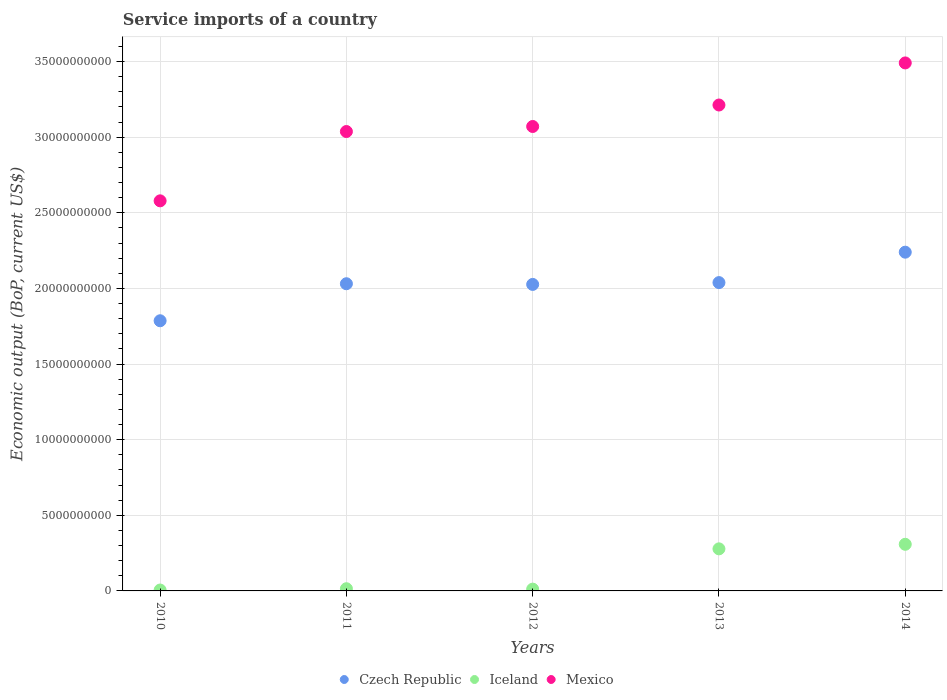How many different coloured dotlines are there?
Ensure brevity in your answer.  3. What is the service imports in Mexico in 2011?
Keep it short and to the point. 3.04e+1. Across all years, what is the maximum service imports in Iceland?
Provide a succinct answer. 3.08e+09. Across all years, what is the minimum service imports in Iceland?
Keep it short and to the point. 5.89e+07. In which year was the service imports in Czech Republic maximum?
Provide a short and direct response. 2014. What is the total service imports in Mexico in the graph?
Provide a succinct answer. 1.54e+11. What is the difference between the service imports in Mexico in 2010 and that in 2012?
Offer a very short reply. -4.92e+09. What is the difference between the service imports in Iceland in 2011 and the service imports in Mexico in 2012?
Ensure brevity in your answer.  -3.06e+1. What is the average service imports in Iceland per year?
Your response must be concise. 1.24e+09. In the year 2012, what is the difference between the service imports in Czech Republic and service imports in Mexico?
Your response must be concise. -1.04e+1. What is the ratio of the service imports in Mexico in 2011 to that in 2012?
Your answer should be compact. 0.99. Is the service imports in Mexico in 2011 less than that in 2014?
Keep it short and to the point. Yes. What is the difference between the highest and the second highest service imports in Mexico?
Offer a terse response. 2.78e+09. What is the difference between the highest and the lowest service imports in Czech Republic?
Give a very brief answer. 4.53e+09. In how many years, is the service imports in Czech Republic greater than the average service imports in Czech Republic taken over all years?
Offer a terse response. 4. Is it the case that in every year, the sum of the service imports in Iceland and service imports in Czech Republic  is greater than the service imports in Mexico?
Your answer should be compact. No. Does the service imports in Iceland monotonically increase over the years?
Make the answer very short. No. Is the service imports in Czech Republic strictly less than the service imports in Mexico over the years?
Offer a terse response. Yes. How many years are there in the graph?
Provide a short and direct response. 5. Are the values on the major ticks of Y-axis written in scientific E-notation?
Provide a short and direct response. No. Does the graph contain grids?
Your response must be concise. Yes. What is the title of the graph?
Give a very brief answer. Service imports of a country. What is the label or title of the Y-axis?
Offer a very short reply. Economic output (BoP, current US$). What is the Economic output (BoP, current US$) in Czech Republic in 2010?
Provide a short and direct response. 1.79e+1. What is the Economic output (BoP, current US$) in Iceland in 2010?
Your answer should be very brief. 5.89e+07. What is the Economic output (BoP, current US$) in Mexico in 2010?
Provide a succinct answer. 2.58e+1. What is the Economic output (BoP, current US$) of Czech Republic in 2011?
Your answer should be very brief. 2.03e+1. What is the Economic output (BoP, current US$) in Iceland in 2011?
Provide a succinct answer. 1.45e+08. What is the Economic output (BoP, current US$) of Mexico in 2011?
Keep it short and to the point. 3.04e+1. What is the Economic output (BoP, current US$) in Czech Republic in 2012?
Keep it short and to the point. 2.03e+1. What is the Economic output (BoP, current US$) of Iceland in 2012?
Provide a succinct answer. 1.18e+08. What is the Economic output (BoP, current US$) in Mexico in 2012?
Your answer should be very brief. 3.07e+1. What is the Economic output (BoP, current US$) in Czech Republic in 2013?
Provide a short and direct response. 2.04e+1. What is the Economic output (BoP, current US$) in Iceland in 2013?
Ensure brevity in your answer.  2.78e+09. What is the Economic output (BoP, current US$) in Mexico in 2013?
Your response must be concise. 3.21e+1. What is the Economic output (BoP, current US$) of Czech Republic in 2014?
Provide a short and direct response. 2.24e+1. What is the Economic output (BoP, current US$) of Iceland in 2014?
Keep it short and to the point. 3.08e+09. What is the Economic output (BoP, current US$) in Mexico in 2014?
Provide a short and direct response. 3.49e+1. Across all years, what is the maximum Economic output (BoP, current US$) in Czech Republic?
Make the answer very short. 2.24e+1. Across all years, what is the maximum Economic output (BoP, current US$) of Iceland?
Make the answer very short. 3.08e+09. Across all years, what is the maximum Economic output (BoP, current US$) in Mexico?
Provide a short and direct response. 3.49e+1. Across all years, what is the minimum Economic output (BoP, current US$) in Czech Republic?
Provide a succinct answer. 1.79e+1. Across all years, what is the minimum Economic output (BoP, current US$) of Iceland?
Provide a short and direct response. 5.89e+07. Across all years, what is the minimum Economic output (BoP, current US$) of Mexico?
Make the answer very short. 2.58e+1. What is the total Economic output (BoP, current US$) in Czech Republic in the graph?
Your answer should be compact. 1.01e+11. What is the total Economic output (BoP, current US$) in Iceland in the graph?
Keep it short and to the point. 6.19e+09. What is the total Economic output (BoP, current US$) of Mexico in the graph?
Ensure brevity in your answer.  1.54e+11. What is the difference between the Economic output (BoP, current US$) of Czech Republic in 2010 and that in 2011?
Your answer should be compact. -2.45e+09. What is the difference between the Economic output (BoP, current US$) of Iceland in 2010 and that in 2011?
Make the answer very short. -8.66e+07. What is the difference between the Economic output (BoP, current US$) in Mexico in 2010 and that in 2011?
Your answer should be very brief. -4.58e+09. What is the difference between the Economic output (BoP, current US$) in Czech Republic in 2010 and that in 2012?
Give a very brief answer. -2.40e+09. What is the difference between the Economic output (BoP, current US$) of Iceland in 2010 and that in 2012?
Your answer should be very brief. -5.94e+07. What is the difference between the Economic output (BoP, current US$) of Mexico in 2010 and that in 2012?
Your response must be concise. -4.92e+09. What is the difference between the Economic output (BoP, current US$) in Czech Republic in 2010 and that in 2013?
Provide a succinct answer. -2.52e+09. What is the difference between the Economic output (BoP, current US$) in Iceland in 2010 and that in 2013?
Give a very brief answer. -2.72e+09. What is the difference between the Economic output (BoP, current US$) of Mexico in 2010 and that in 2013?
Your answer should be very brief. -6.34e+09. What is the difference between the Economic output (BoP, current US$) in Czech Republic in 2010 and that in 2014?
Offer a terse response. -4.53e+09. What is the difference between the Economic output (BoP, current US$) in Iceland in 2010 and that in 2014?
Your response must be concise. -3.02e+09. What is the difference between the Economic output (BoP, current US$) in Mexico in 2010 and that in 2014?
Ensure brevity in your answer.  -9.12e+09. What is the difference between the Economic output (BoP, current US$) in Czech Republic in 2011 and that in 2012?
Your response must be concise. 4.52e+07. What is the difference between the Economic output (BoP, current US$) of Iceland in 2011 and that in 2012?
Your answer should be compact. 2.72e+07. What is the difference between the Economic output (BoP, current US$) of Mexico in 2011 and that in 2012?
Your response must be concise. -3.33e+08. What is the difference between the Economic output (BoP, current US$) of Czech Republic in 2011 and that in 2013?
Provide a succinct answer. -7.53e+07. What is the difference between the Economic output (BoP, current US$) in Iceland in 2011 and that in 2013?
Offer a very short reply. -2.64e+09. What is the difference between the Economic output (BoP, current US$) in Mexico in 2011 and that in 2013?
Your answer should be very brief. -1.75e+09. What is the difference between the Economic output (BoP, current US$) of Czech Republic in 2011 and that in 2014?
Your answer should be compact. -2.09e+09. What is the difference between the Economic output (BoP, current US$) in Iceland in 2011 and that in 2014?
Make the answer very short. -2.94e+09. What is the difference between the Economic output (BoP, current US$) in Mexico in 2011 and that in 2014?
Make the answer very short. -4.54e+09. What is the difference between the Economic output (BoP, current US$) of Czech Republic in 2012 and that in 2013?
Make the answer very short. -1.21e+08. What is the difference between the Economic output (BoP, current US$) of Iceland in 2012 and that in 2013?
Provide a succinct answer. -2.66e+09. What is the difference between the Economic output (BoP, current US$) of Mexico in 2012 and that in 2013?
Keep it short and to the point. -1.42e+09. What is the difference between the Economic output (BoP, current US$) in Czech Republic in 2012 and that in 2014?
Make the answer very short. -2.13e+09. What is the difference between the Economic output (BoP, current US$) of Iceland in 2012 and that in 2014?
Give a very brief answer. -2.96e+09. What is the difference between the Economic output (BoP, current US$) in Mexico in 2012 and that in 2014?
Give a very brief answer. -4.20e+09. What is the difference between the Economic output (BoP, current US$) in Czech Republic in 2013 and that in 2014?
Ensure brevity in your answer.  -2.01e+09. What is the difference between the Economic output (BoP, current US$) in Iceland in 2013 and that in 2014?
Keep it short and to the point. -3.01e+08. What is the difference between the Economic output (BoP, current US$) of Mexico in 2013 and that in 2014?
Provide a short and direct response. -2.78e+09. What is the difference between the Economic output (BoP, current US$) in Czech Republic in 2010 and the Economic output (BoP, current US$) in Iceland in 2011?
Offer a terse response. 1.77e+1. What is the difference between the Economic output (BoP, current US$) in Czech Republic in 2010 and the Economic output (BoP, current US$) in Mexico in 2011?
Provide a succinct answer. -1.25e+1. What is the difference between the Economic output (BoP, current US$) in Iceland in 2010 and the Economic output (BoP, current US$) in Mexico in 2011?
Your response must be concise. -3.03e+1. What is the difference between the Economic output (BoP, current US$) in Czech Republic in 2010 and the Economic output (BoP, current US$) in Iceland in 2012?
Keep it short and to the point. 1.77e+1. What is the difference between the Economic output (BoP, current US$) of Czech Republic in 2010 and the Economic output (BoP, current US$) of Mexico in 2012?
Keep it short and to the point. -1.28e+1. What is the difference between the Economic output (BoP, current US$) in Iceland in 2010 and the Economic output (BoP, current US$) in Mexico in 2012?
Give a very brief answer. -3.06e+1. What is the difference between the Economic output (BoP, current US$) in Czech Republic in 2010 and the Economic output (BoP, current US$) in Iceland in 2013?
Provide a short and direct response. 1.51e+1. What is the difference between the Economic output (BoP, current US$) of Czech Republic in 2010 and the Economic output (BoP, current US$) of Mexico in 2013?
Offer a very short reply. -1.43e+1. What is the difference between the Economic output (BoP, current US$) of Iceland in 2010 and the Economic output (BoP, current US$) of Mexico in 2013?
Provide a succinct answer. -3.21e+1. What is the difference between the Economic output (BoP, current US$) in Czech Republic in 2010 and the Economic output (BoP, current US$) in Iceland in 2014?
Keep it short and to the point. 1.48e+1. What is the difference between the Economic output (BoP, current US$) in Czech Republic in 2010 and the Economic output (BoP, current US$) in Mexico in 2014?
Your response must be concise. -1.70e+1. What is the difference between the Economic output (BoP, current US$) in Iceland in 2010 and the Economic output (BoP, current US$) in Mexico in 2014?
Offer a terse response. -3.49e+1. What is the difference between the Economic output (BoP, current US$) of Czech Republic in 2011 and the Economic output (BoP, current US$) of Iceland in 2012?
Ensure brevity in your answer.  2.02e+1. What is the difference between the Economic output (BoP, current US$) in Czech Republic in 2011 and the Economic output (BoP, current US$) in Mexico in 2012?
Offer a very short reply. -1.04e+1. What is the difference between the Economic output (BoP, current US$) of Iceland in 2011 and the Economic output (BoP, current US$) of Mexico in 2012?
Give a very brief answer. -3.06e+1. What is the difference between the Economic output (BoP, current US$) of Czech Republic in 2011 and the Economic output (BoP, current US$) of Iceland in 2013?
Your answer should be compact. 1.75e+1. What is the difference between the Economic output (BoP, current US$) in Czech Republic in 2011 and the Economic output (BoP, current US$) in Mexico in 2013?
Make the answer very short. -1.18e+1. What is the difference between the Economic output (BoP, current US$) in Iceland in 2011 and the Economic output (BoP, current US$) in Mexico in 2013?
Offer a very short reply. -3.20e+1. What is the difference between the Economic output (BoP, current US$) in Czech Republic in 2011 and the Economic output (BoP, current US$) in Iceland in 2014?
Offer a terse response. 1.72e+1. What is the difference between the Economic output (BoP, current US$) in Czech Republic in 2011 and the Economic output (BoP, current US$) in Mexico in 2014?
Offer a terse response. -1.46e+1. What is the difference between the Economic output (BoP, current US$) of Iceland in 2011 and the Economic output (BoP, current US$) of Mexico in 2014?
Keep it short and to the point. -3.48e+1. What is the difference between the Economic output (BoP, current US$) of Czech Republic in 2012 and the Economic output (BoP, current US$) of Iceland in 2013?
Ensure brevity in your answer.  1.75e+1. What is the difference between the Economic output (BoP, current US$) in Czech Republic in 2012 and the Economic output (BoP, current US$) in Mexico in 2013?
Give a very brief answer. -1.19e+1. What is the difference between the Economic output (BoP, current US$) in Iceland in 2012 and the Economic output (BoP, current US$) in Mexico in 2013?
Your answer should be very brief. -3.20e+1. What is the difference between the Economic output (BoP, current US$) in Czech Republic in 2012 and the Economic output (BoP, current US$) in Iceland in 2014?
Keep it short and to the point. 1.72e+1. What is the difference between the Economic output (BoP, current US$) in Czech Republic in 2012 and the Economic output (BoP, current US$) in Mexico in 2014?
Your answer should be very brief. -1.46e+1. What is the difference between the Economic output (BoP, current US$) of Iceland in 2012 and the Economic output (BoP, current US$) of Mexico in 2014?
Keep it short and to the point. -3.48e+1. What is the difference between the Economic output (BoP, current US$) of Czech Republic in 2013 and the Economic output (BoP, current US$) of Iceland in 2014?
Your response must be concise. 1.73e+1. What is the difference between the Economic output (BoP, current US$) in Czech Republic in 2013 and the Economic output (BoP, current US$) in Mexico in 2014?
Your answer should be compact. -1.45e+1. What is the difference between the Economic output (BoP, current US$) of Iceland in 2013 and the Economic output (BoP, current US$) of Mexico in 2014?
Provide a succinct answer. -3.21e+1. What is the average Economic output (BoP, current US$) in Czech Republic per year?
Provide a short and direct response. 2.02e+1. What is the average Economic output (BoP, current US$) of Iceland per year?
Provide a short and direct response. 1.24e+09. What is the average Economic output (BoP, current US$) in Mexico per year?
Your answer should be very brief. 3.08e+1. In the year 2010, what is the difference between the Economic output (BoP, current US$) of Czech Republic and Economic output (BoP, current US$) of Iceland?
Provide a succinct answer. 1.78e+1. In the year 2010, what is the difference between the Economic output (BoP, current US$) in Czech Republic and Economic output (BoP, current US$) in Mexico?
Your answer should be compact. -7.93e+09. In the year 2010, what is the difference between the Economic output (BoP, current US$) of Iceland and Economic output (BoP, current US$) of Mexico?
Your answer should be compact. -2.57e+1. In the year 2011, what is the difference between the Economic output (BoP, current US$) in Czech Republic and Economic output (BoP, current US$) in Iceland?
Give a very brief answer. 2.02e+1. In the year 2011, what is the difference between the Economic output (BoP, current US$) of Czech Republic and Economic output (BoP, current US$) of Mexico?
Your response must be concise. -1.01e+1. In the year 2011, what is the difference between the Economic output (BoP, current US$) of Iceland and Economic output (BoP, current US$) of Mexico?
Keep it short and to the point. -3.02e+1. In the year 2012, what is the difference between the Economic output (BoP, current US$) of Czech Republic and Economic output (BoP, current US$) of Iceland?
Provide a succinct answer. 2.01e+1. In the year 2012, what is the difference between the Economic output (BoP, current US$) in Czech Republic and Economic output (BoP, current US$) in Mexico?
Your answer should be very brief. -1.04e+1. In the year 2012, what is the difference between the Economic output (BoP, current US$) of Iceland and Economic output (BoP, current US$) of Mexico?
Your answer should be compact. -3.06e+1. In the year 2013, what is the difference between the Economic output (BoP, current US$) of Czech Republic and Economic output (BoP, current US$) of Iceland?
Provide a short and direct response. 1.76e+1. In the year 2013, what is the difference between the Economic output (BoP, current US$) of Czech Republic and Economic output (BoP, current US$) of Mexico?
Give a very brief answer. -1.17e+1. In the year 2013, what is the difference between the Economic output (BoP, current US$) in Iceland and Economic output (BoP, current US$) in Mexico?
Give a very brief answer. -2.93e+1. In the year 2014, what is the difference between the Economic output (BoP, current US$) in Czech Republic and Economic output (BoP, current US$) in Iceland?
Provide a short and direct response. 1.93e+1. In the year 2014, what is the difference between the Economic output (BoP, current US$) of Czech Republic and Economic output (BoP, current US$) of Mexico?
Your answer should be very brief. -1.25e+1. In the year 2014, what is the difference between the Economic output (BoP, current US$) of Iceland and Economic output (BoP, current US$) of Mexico?
Offer a terse response. -3.18e+1. What is the ratio of the Economic output (BoP, current US$) of Czech Republic in 2010 to that in 2011?
Your answer should be very brief. 0.88. What is the ratio of the Economic output (BoP, current US$) in Iceland in 2010 to that in 2011?
Offer a very short reply. 0.4. What is the ratio of the Economic output (BoP, current US$) in Mexico in 2010 to that in 2011?
Offer a terse response. 0.85. What is the ratio of the Economic output (BoP, current US$) of Czech Republic in 2010 to that in 2012?
Your answer should be very brief. 0.88. What is the ratio of the Economic output (BoP, current US$) in Iceland in 2010 to that in 2012?
Give a very brief answer. 0.5. What is the ratio of the Economic output (BoP, current US$) in Mexico in 2010 to that in 2012?
Keep it short and to the point. 0.84. What is the ratio of the Economic output (BoP, current US$) of Czech Republic in 2010 to that in 2013?
Your answer should be compact. 0.88. What is the ratio of the Economic output (BoP, current US$) of Iceland in 2010 to that in 2013?
Offer a very short reply. 0.02. What is the ratio of the Economic output (BoP, current US$) in Mexico in 2010 to that in 2013?
Offer a very short reply. 0.8. What is the ratio of the Economic output (BoP, current US$) of Czech Republic in 2010 to that in 2014?
Your answer should be compact. 0.8. What is the ratio of the Economic output (BoP, current US$) of Iceland in 2010 to that in 2014?
Offer a terse response. 0.02. What is the ratio of the Economic output (BoP, current US$) in Mexico in 2010 to that in 2014?
Offer a very short reply. 0.74. What is the ratio of the Economic output (BoP, current US$) in Czech Republic in 2011 to that in 2012?
Your answer should be very brief. 1. What is the ratio of the Economic output (BoP, current US$) in Iceland in 2011 to that in 2012?
Offer a very short reply. 1.23. What is the ratio of the Economic output (BoP, current US$) in Czech Republic in 2011 to that in 2013?
Offer a terse response. 1. What is the ratio of the Economic output (BoP, current US$) of Iceland in 2011 to that in 2013?
Ensure brevity in your answer.  0.05. What is the ratio of the Economic output (BoP, current US$) of Mexico in 2011 to that in 2013?
Ensure brevity in your answer.  0.95. What is the ratio of the Economic output (BoP, current US$) in Czech Republic in 2011 to that in 2014?
Make the answer very short. 0.91. What is the ratio of the Economic output (BoP, current US$) of Iceland in 2011 to that in 2014?
Make the answer very short. 0.05. What is the ratio of the Economic output (BoP, current US$) of Mexico in 2011 to that in 2014?
Your response must be concise. 0.87. What is the ratio of the Economic output (BoP, current US$) in Iceland in 2012 to that in 2013?
Provide a succinct answer. 0.04. What is the ratio of the Economic output (BoP, current US$) of Mexico in 2012 to that in 2013?
Your answer should be very brief. 0.96. What is the ratio of the Economic output (BoP, current US$) of Czech Republic in 2012 to that in 2014?
Keep it short and to the point. 0.9. What is the ratio of the Economic output (BoP, current US$) in Iceland in 2012 to that in 2014?
Provide a succinct answer. 0.04. What is the ratio of the Economic output (BoP, current US$) of Mexico in 2012 to that in 2014?
Ensure brevity in your answer.  0.88. What is the ratio of the Economic output (BoP, current US$) of Czech Republic in 2013 to that in 2014?
Your response must be concise. 0.91. What is the ratio of the Economic output (BoP, current US$) in Iceland in 2013 to that in 2014?
Provide a succinct answer. 0.9. What is the ratio of the Economic output (BoP, current US$) of Mexico in 2013 to that in 2014?
Ensure brevity in your answer.  0.92. What is the difference between the highest and the second highest Economic output (BoP, current US$) of Czech Republic?
Provide a short and direct response. 2.01e+09. What is the difference between the highest and the second highest Economic output (BoP, current US$) of Iceland?
Make the answer very short. 3.01e+08. What is the difference between the highest and the second highest Economic output (BoP, current US$) of Mexico?
Provide a short and direct response. 2.78e+09. What is the difference between the highest and the lowest Economic output (BoP, current US$) in Czech Republic?
Offer a very short reply. 4.53e+09. What is the difference between the highest and the lowest Economic output (BoP, current US$) of Iceland?
Keep it short and to the point. 3.02e+09. What is the difference between the highest and the lowest Economic output (BoP, current US$) of Mexico?
Your answer should be very brief. 9.12e+09. 